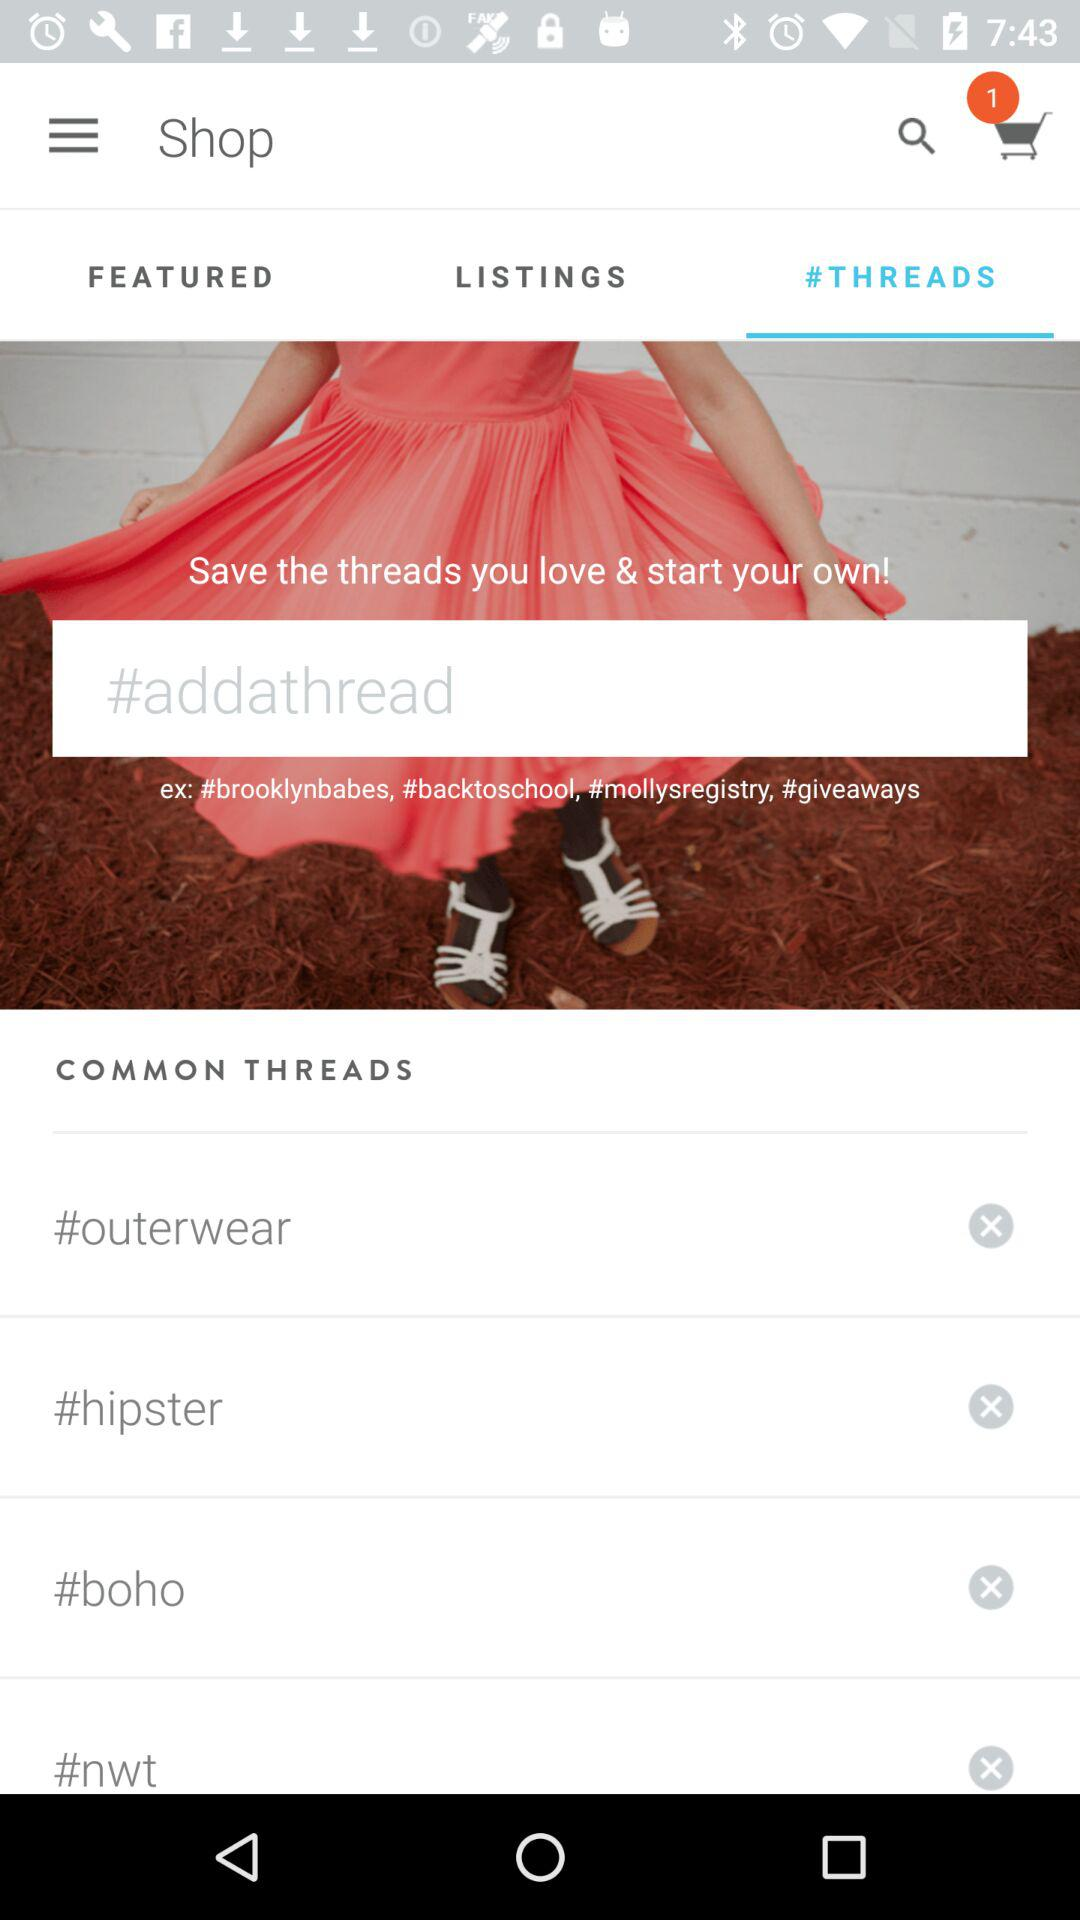What is the number of items added to the cart? The number of items added to the cart is 1. 